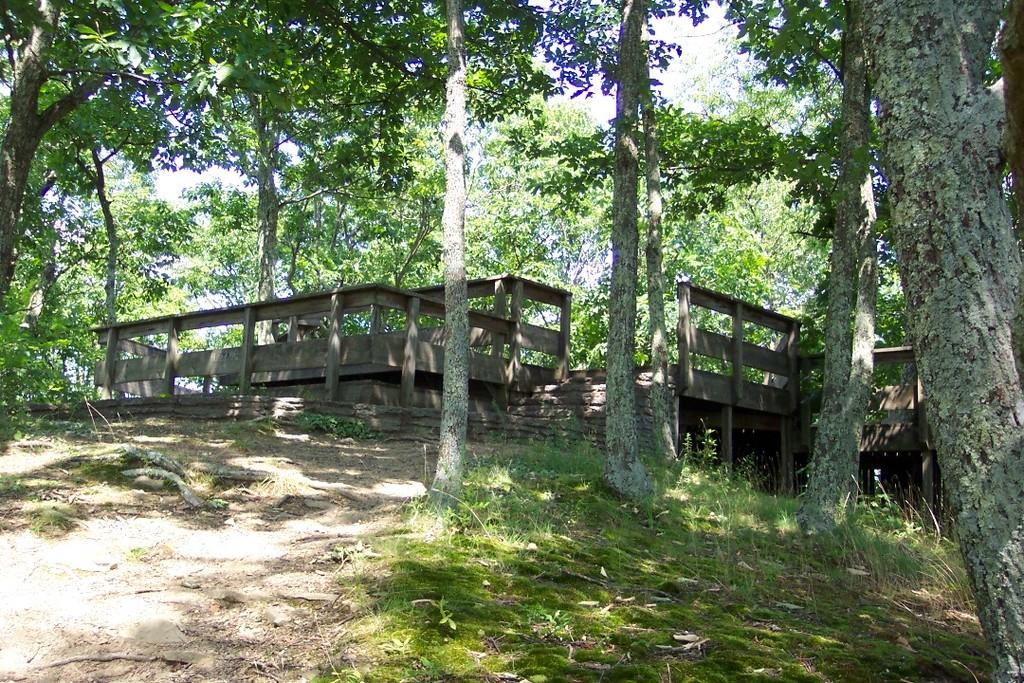What type of vegetation can be seen in the image? There are many trees, plants, and grass in the image. What kind of pathway is present in the image? There is a walkway in the image. What structures are present to provide support or guidance? There are wooden poles and railing in the image. How can someone navigate between different levels in the image? There are stairs in the image for navigating between different levels. What can be seen in the background of the image? The sky is visible in the background of the image. What type of comfort can be found in the town depicted in the image? There is no town depicted in the image, and therefore no comfort can be found in a town within the image. What type of pump is used to irrigate the plants in the image? There is no pump present in the image; the plants are not being irrigated. 